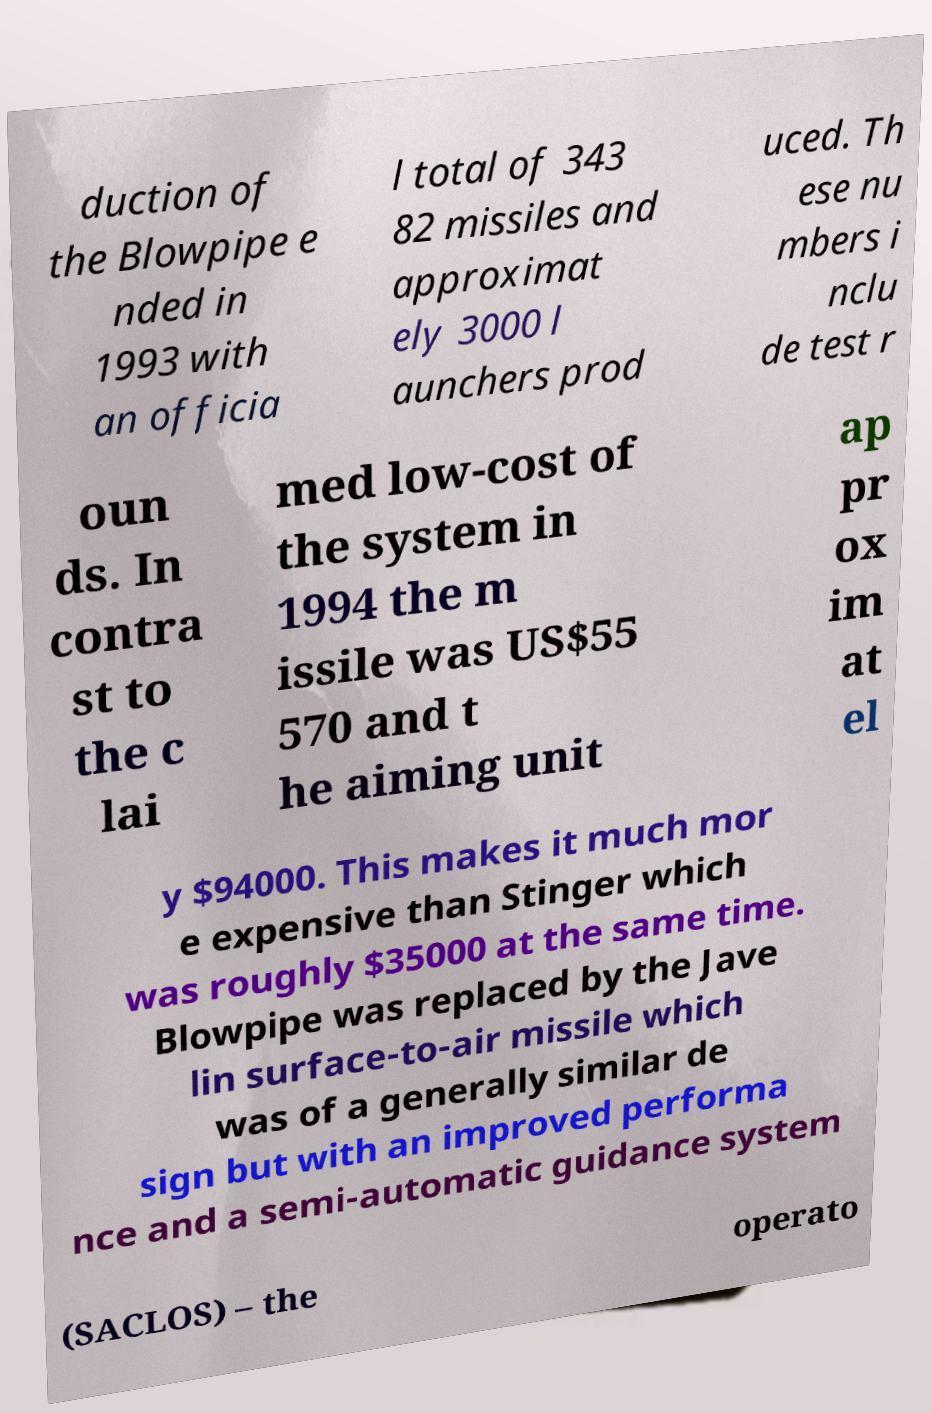Can you accurately transcribe the text from the provided image for me? duction of the Blowpipe e nded in 1993 with an officia l total of 343 82 missiles and approximat ely 3000 l aunchers prod uced. Th ese nu mbers i nclu de test r oun ds. In contra st to the c lai med low-cost of the system in 1994 the m issile was US$55 570 and t he aiming unit ap pr ox im at el y $94000. This makes it much mor e expensive than Stinger which was roughly $35000 at the same time. Blowpipe was replaced by the Jave lin surface-to-air missile which was of a generally similar de sign but with an improved performa nce and a semi-automatic guidance system (SACLOS) – the operato 